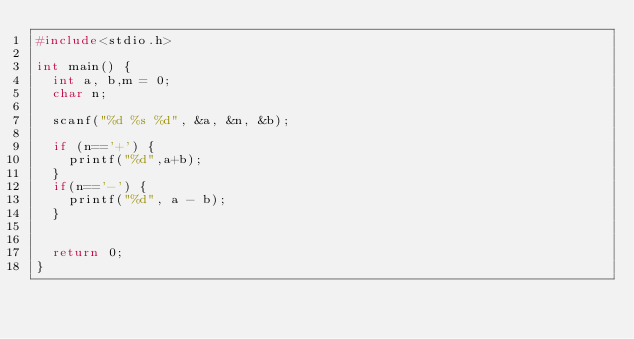<code> <loc_0><loc_0><loc_500><loc_500><_C_>#include<stdio.h>

int main() {
	int a, b,m = 0;
	char n;

	scanf("%d %s %d", &a, &n, &b);

	if (n=='+') {
		printf("%d",a+b);
	}
	if(n=='-') {
		printf("%d", a - b);
	}


	return 0;
}</code> 